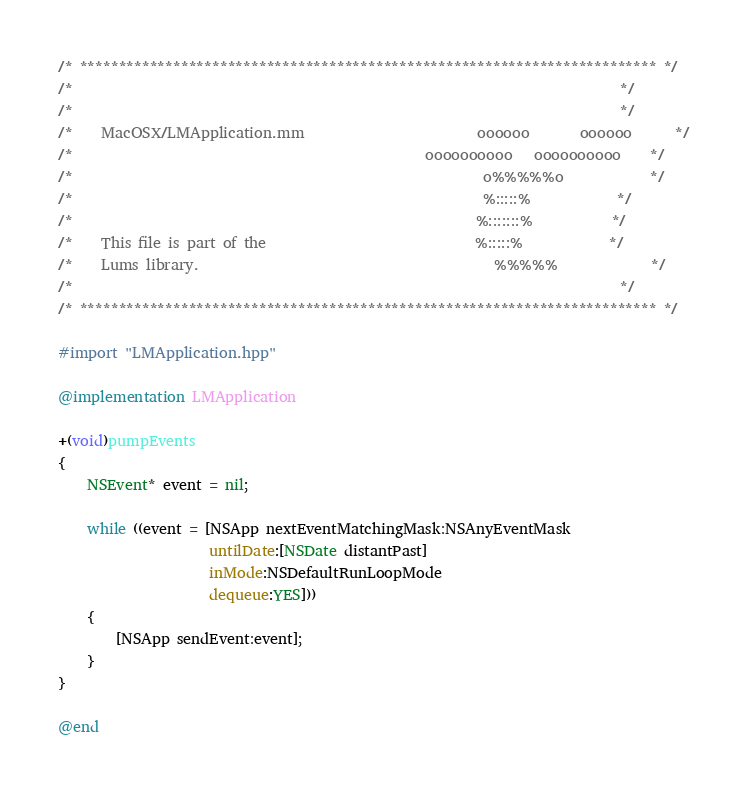<code> <loc_0><loc_0><loc_500><loc_500><_ObjectiveC_>/* ************************************************************************** */
/*                                                                            */
/*                                                                            */
/*    MacOSX/LMApplication.mm                        oooooo       oooooo      */
/*                                                 oooooooooo   oooooooooo    */
/*                                                         o%%%%%o            */
/*                                                         %:::::%            */
/*                                                        %:::::::%           */
/*    This file is part of the                             %:::::%            */
/*    Lums library.                                         %%%%%             */
/*                                                                            */
/* ************************************************************************** */

#import "LMApplication.hpp"

@implementation LMApplication

+(void)pumpEvents
{
    NSEvent* event = nil;

    while ((event = [NSApp nextEventMatchingMask:NSAnyEventMask
                     untilDate:[NSDate distantPast]
                     inMode:NSDefaultRunLoopMode
                     dequeue:YES]))
    {
        [NSApp sendEvent:event];
    }
}

@end</code> 